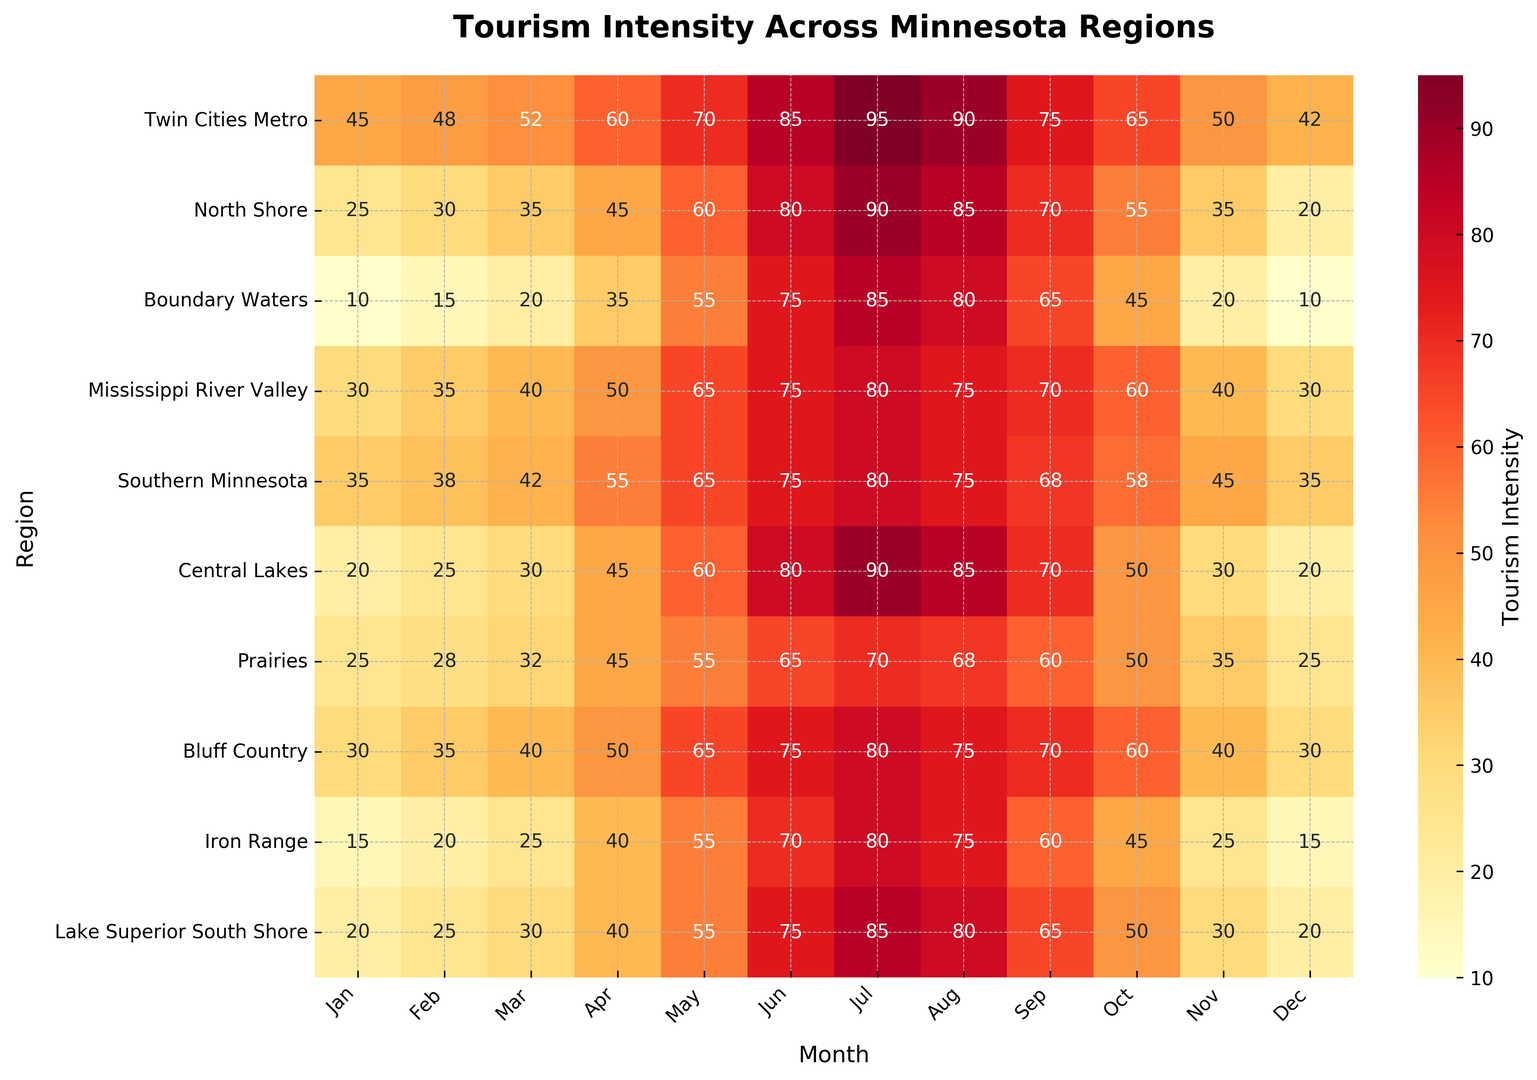Which region experiences the highest tourism intensity in July? Look at the values in the July column and identify the highest numerical value. The maximum observed value is 95 for the Twin Cities Metro region.
Answer: Twin Cities Metro Compare the tourism intensity between the Twin Cities Metro and the North Shore in December. Which region has a higher intensity, and by how much? Locate the values for both regions in the December column: Twin Cities Metro (42) and North Shore (20). Subtract the lower value from the higher value: 42 - 20 = 22.
Answer: Twin Cities Metro by 22 What's the average tourism intensity in June across all regions? Add up all the values in the June column and divide by the number of regions (10): (85 + 80 + 75 + 75 + 75 + 80 + 65 + 75 + 70 + 75) / 10 = 75.5.
Answer: 75.5 Which region has the lowest tourism intensity in March, and what is that value? Observe the values in the March column and find the smallest number. The lowest value is 20 for Boundary Waters.
Answer: Boundary Waters, 20 In which month does Bluff Country experience its peak tourism intensity? Traverse the values for Bluff Country row and identify the maximum value. The highest intensity is 80, observed in July.
Answer: July What is the change in tourism intensity for the Southern Minnesota region from April to August? Locate Southern Minnesota values for April (55) and August (75), then compute the difference: 75 - 55 = 20.
Answer: 20 Which regions have the same tourism intensity value in October? Identify the October column and scan for repeated numbers. Both Mississipi River Valley and Bluff Country have an intensity value of 60.
Answer: Mississipi River Valley and Bluff Country What is the total tourism intensity for Lake Superior South Shore from January to December? Sum all the values in the Lake Superior South Shore row: 20 + 25 + 30 + 40 + 55 + 75 + 85 + 80 + 65 + 50 + 30 + 20 = 575.
Answer: 575 Is there a month where the tourism intensity for Central Lakes and Prairies is the same? If so, what is the month and intensity? Compare values in corresponding columns for Central Lakes and Prairies. Both regions have an intensity of 45 in April.
Answer: April, 45 When looking at the heatmap, which month generally shows the peak tourism intensity across most regions? Observe the heatmap colors and values to notice that July generally shows high intensity values for the majority of regions.
Answer: July 